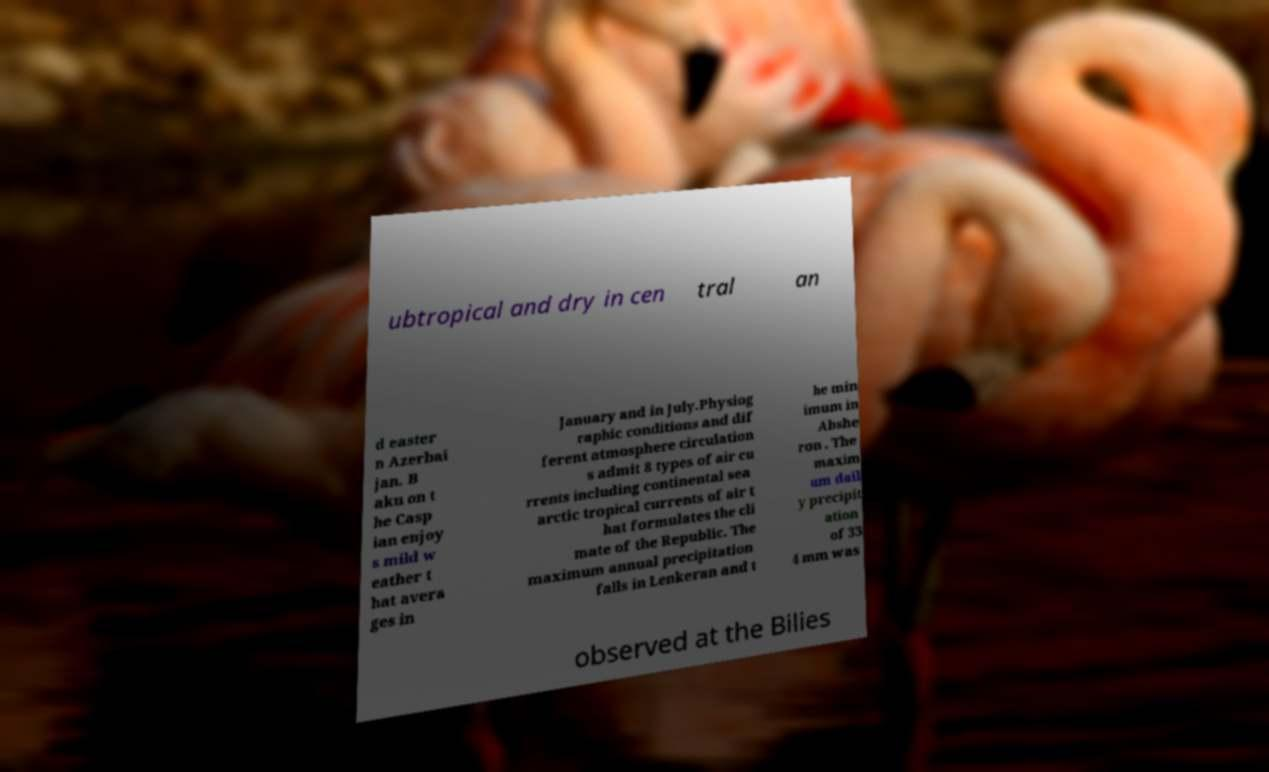What messages or text are displayed in this image? I need them in a readable, typed format. ubtropical and dry in cen tral an d easter n Azerbai jan. B aku on t he Casp ian enjoy s mild w eather t hat avera ges in January and in July.Physiog raphic conditions and dif ferent atmosphere circulation s admit 8 types of air cu rrents including continental sea arctic tropical currents of air t hat formulates the cli mate of the Republic. The maximum annual precipitation falls in Lenkeran and t he min imum in Abshe ron . The maxim um dail y precipit ation of 33 4 mm was observed at the Bilies 